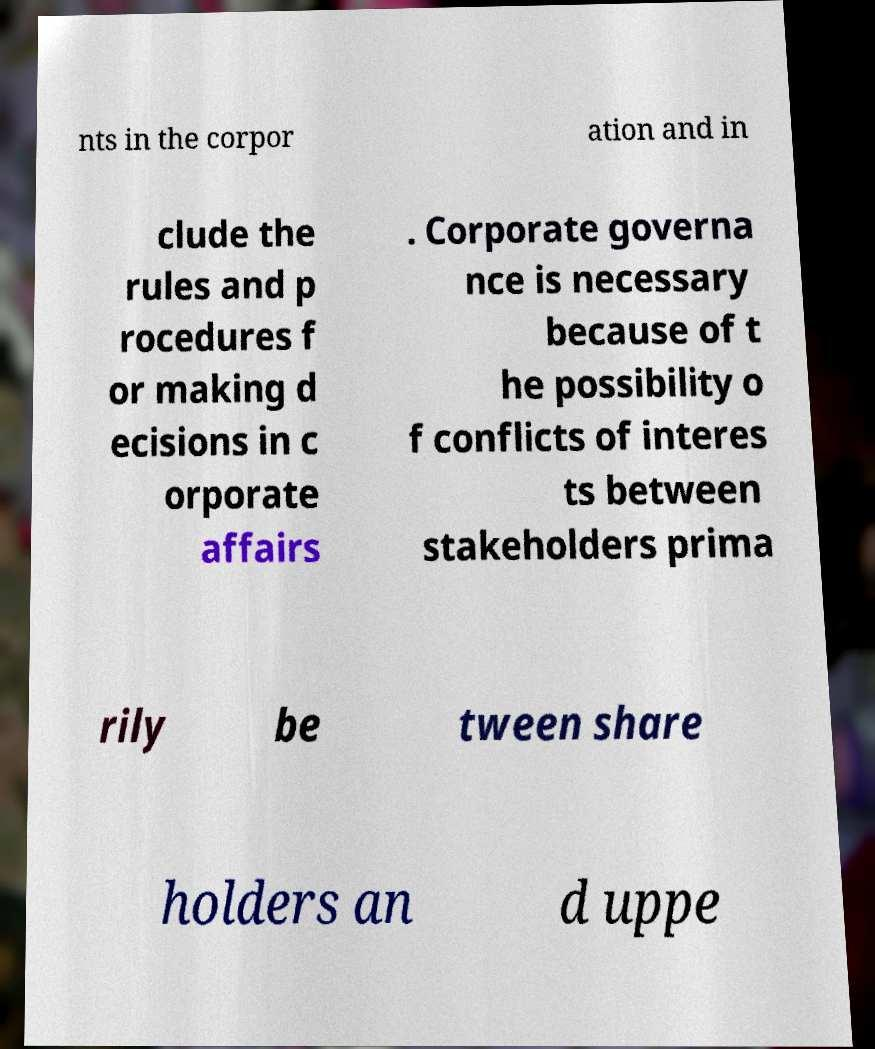There's text embedded in this image that I need extracted. Can you transcribe it verbatim? nts in the corpor ation and in clude the rules and p rocedures f or making d ecisions in c orporate affairs . Corporate governa nce is necessary because of t he possibility o f conflicts of interes ts between stakeholders prima rily be tween share holders an d uppe 